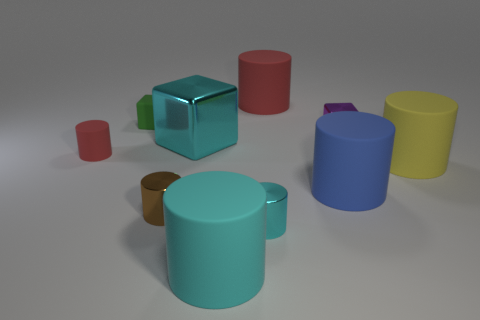Does the small green thing have the same shape as the yellow rubber object? no 